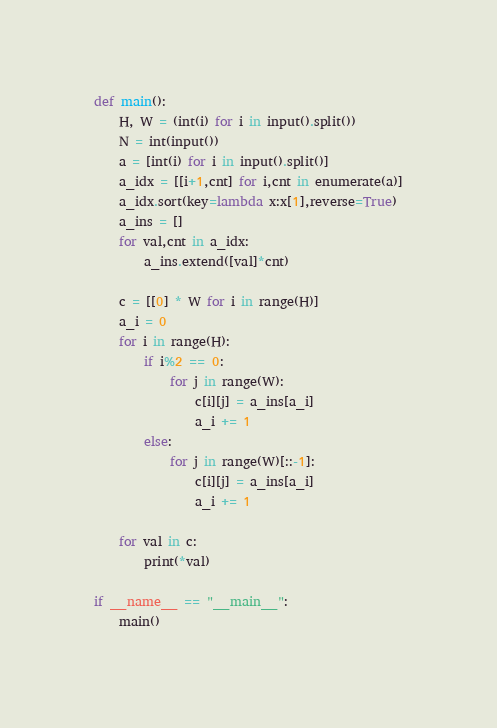Convert code to text. <code><loc_0><loc_0><loc_500><loc_500><_Python_>def main():
    H, W = (int(i) for i in input().split())
    N = int(input())
    a = [int(i) for i in input().split()]
    a_idx = [[i+1,cnt] for i,cnt in enumerate(a)]
    a_idx.sort(key=lambda x:x[1],reverse=True)
    a_ins = []
    for val,cnt in a_idx:
        a_ins.extend([val]*cnt)

    c = [[0] * W for i in range(H)]
    a_i = 0
    for i in range(H):
        if i%2 == 0:
            for j in range(W):
                c[i][j] = a_ins[a_i]
                a_i += 1
        else:
            for j in range(W)[::-1]:
                c[i][j] = a_ins[a_i]
                a_i += 1

    for val in c:
        print(*val)

if __name__ == "__main__":
    main()</code> 